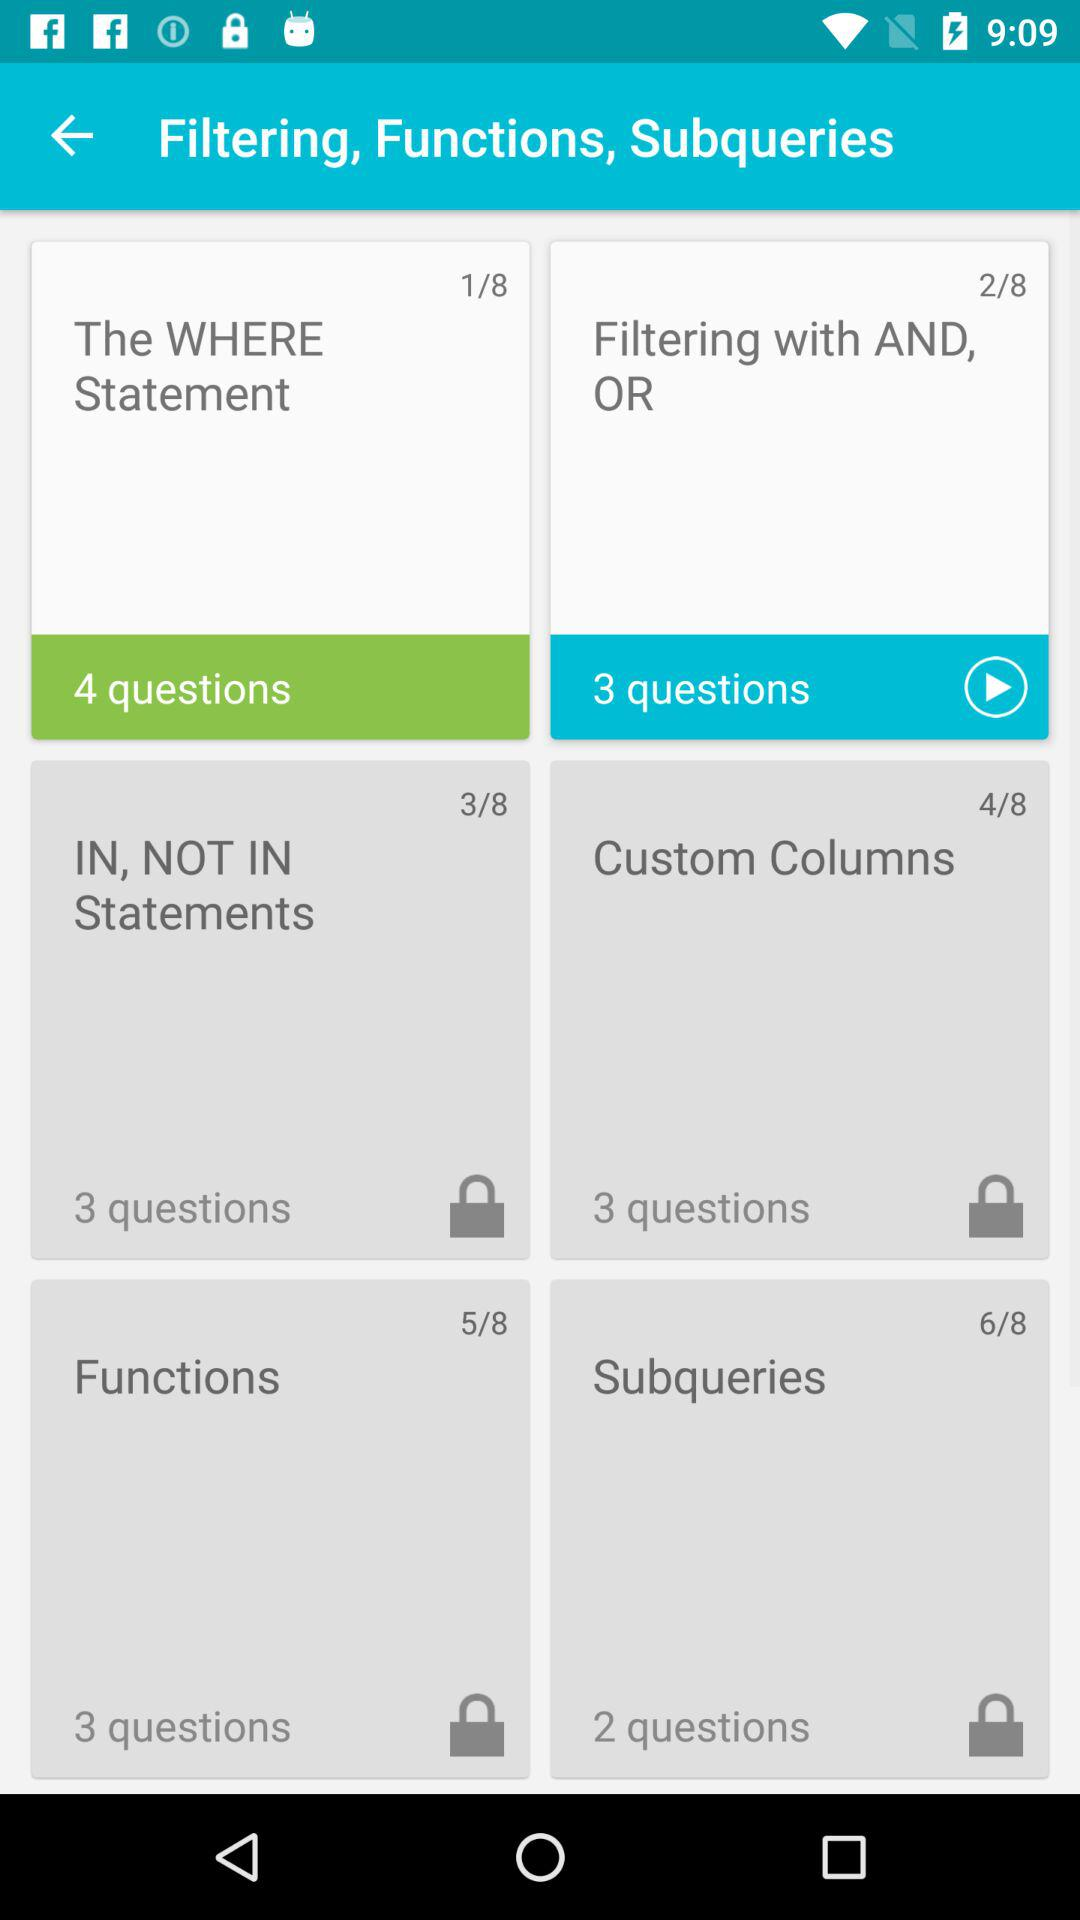What is the number of questions in the "Custom Columns"? The number of questions is 3. 